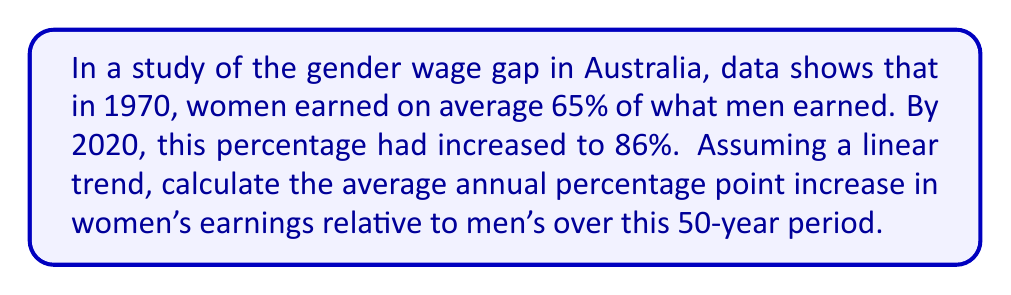Provide a solution to this math problem. To solve this problem, we'll follow these steps:

1. Identify the initial and final percentages:
   - 1970: 65%
   - 2020: 86%

2. Calculate the total percentage point increase:
   $86\% - 65\% = 21$ percentage points

3. Determine the time period:
   $2020 - 1970 = 50$ years

4. Calculate the average annual percentage point increase:
   $$\text{Annual increase} = \frac{\text{Total increase}}{\text{Number of years}}$$
   $$\text{Annual increase} = \frac{21}{50} = 0.42$$

5. Convert to percentage points:
   $0.42$ percentage points per year

This means that, on average, women's earnings as a percentage of men's earnings increased by 0.42 percentage points each year from 1970 to 2020, assuming a linear trend.
Answer: 0.42 percentage points per year 